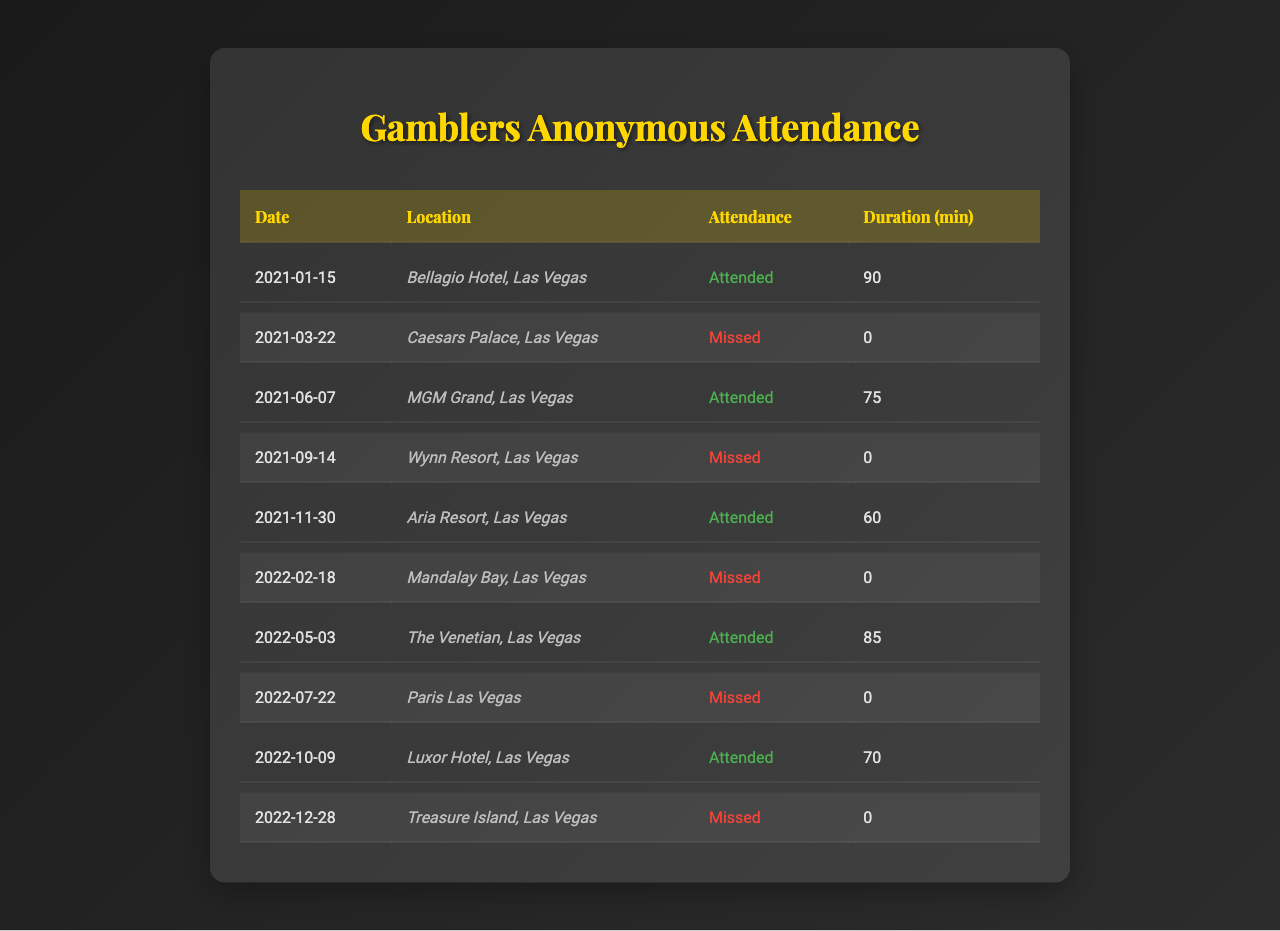What was the total number of meetings attended during the two years? The table lists 10 meetings, and by reviewing the attendance status, we see that there are 5 meetings attended.
Answer: 5 What is the average duration of the meetings that were attended? The durations for attended meetings are 90, 75, 60, 85, and 70 minutes. Summing these gives 90 + 75 + 60 + 85 + 70 = 380 minutes. There are 5 attended meetings, so the average is 380/5 = 76 minutes.
Answer: 76 How many meetings were missed in the year 2021? In 2021, there were 5 meetings listed, and attendance status shows that 2 of those were missed.
Answer: 2 Was there a meeting attended at the Mandalay Bay location? Checking the attendance at Mandalay Bay on February 18, 2022, the table indicates that this meeting was missed.
Answer: No Which meeting had the longest duration that was attended? Looking at the durations of the attended meetings (90, 75, 60, 85, 70), the longest is 90 minutes for the meeting on January 15, 2021.
Answer: 90 minutes What is the percentage of meetings attended out of total meetings? There are 10 meetings total, and 5 were attended. The calculation is (5 attended / 10 total) * 100 = 50%.
Answer: 50% In which month of 2021 was the only meeting not attended? There were two meetings missed in 2021: March and September. Hence, March is the first month with a missed meeting.
Answer: March What locations did meetings occur in during 2022? By examining the table, the locations for attended meetings in 2022 are The Venetian and Luxor Hotel, while missed meetings occurred at Mandalay Bay and Paris Las Vegas.
Answer: The Venetian and Luxor Hotel Was there a significant gap between attended meetings in 2021 and the next attended meeting in 2022? The last attended meeting in 2021 was on November 30, and the next attended meeting was on May 3, 2022, indicating a gap of 5 months.
Answer: Yes How many total unique locations were used for meetings? By counting each unique location in the table, there are 8 distinct ones: Bellagio Hotel, Caesars Palace, MGM Grand, Wynn Resort, Aria Resort, Mandalay Bay, The Venetian, Paris Las Vegas, Luxor Hotel, and Treasure Island.
Answer: 10 